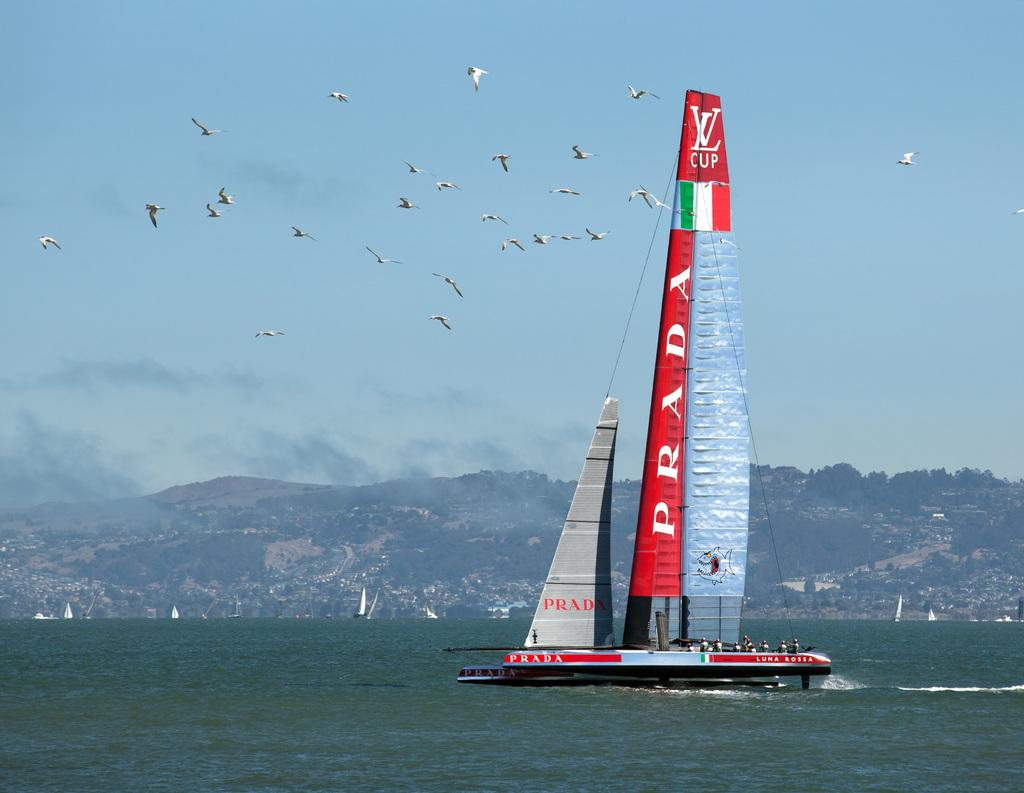<image>
Present a compact description of the photo's key features. a boat that has the word Prada on it 